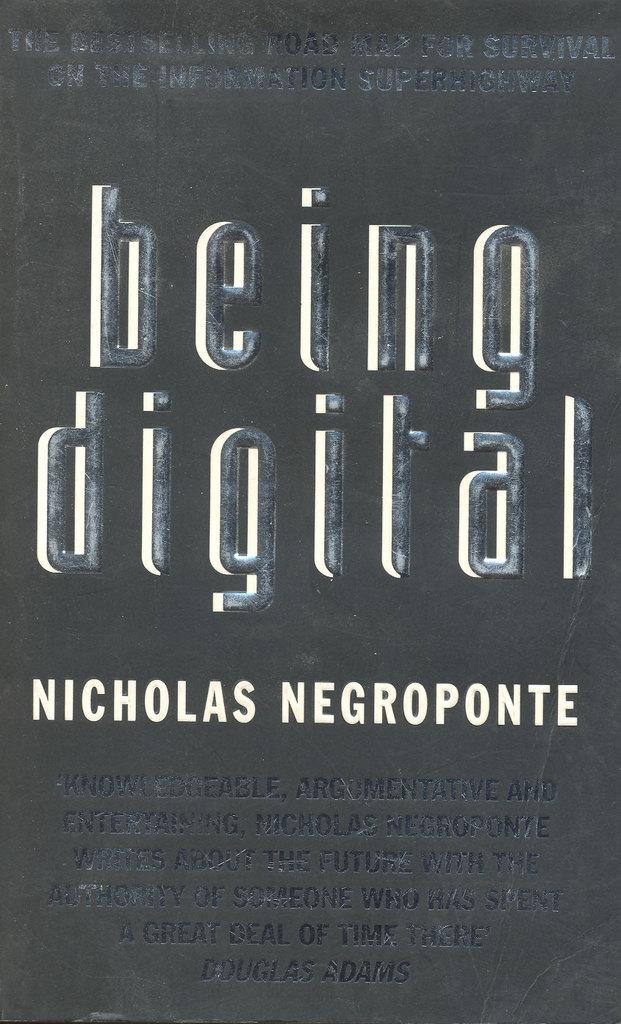What books has nicholas negroponte written?
Your answer should be compact. Being digital. Who authored the book?
Your answer should be very brief. Nicholas negroponte. 